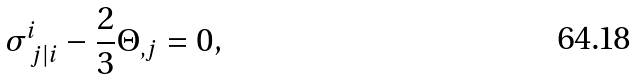<formula> <loc_0><loc_0><loc_500><loc_500>\sigma ^ { i } _ { \ j | i } - \frac { 2 } { 3 } \Theta _ { , j } = 0 ,</formula> 